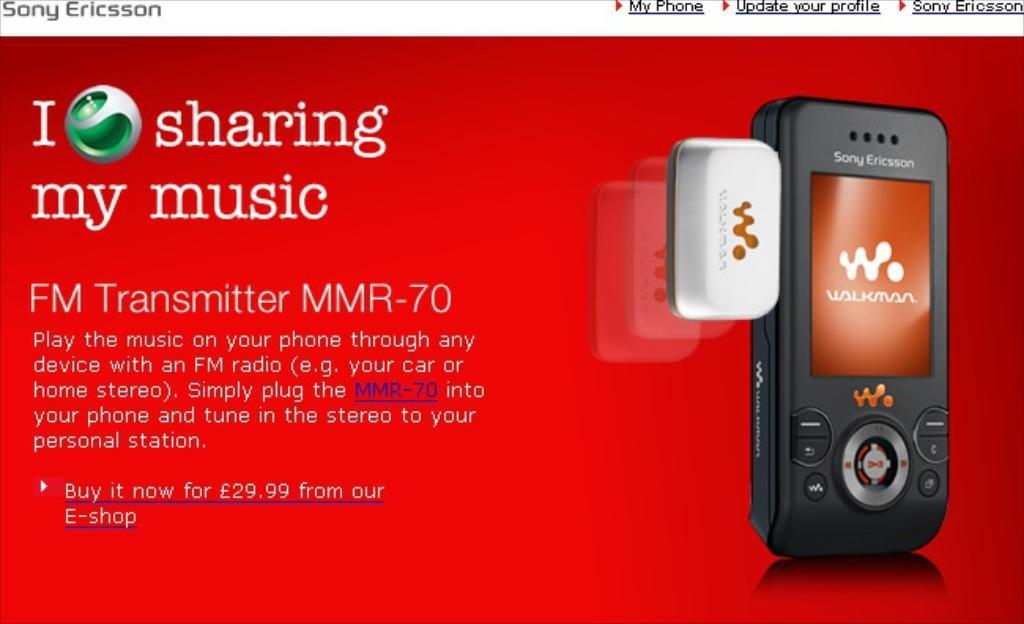<image>
Render a clear and concise summary of the photo. An ad by Sony Ericsson shows an FM transmitter. 